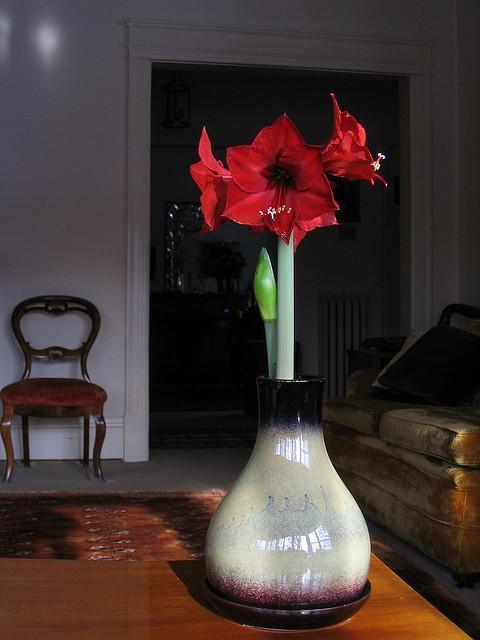How many flowers are in the vase?
Give a very brief answer. 3. 